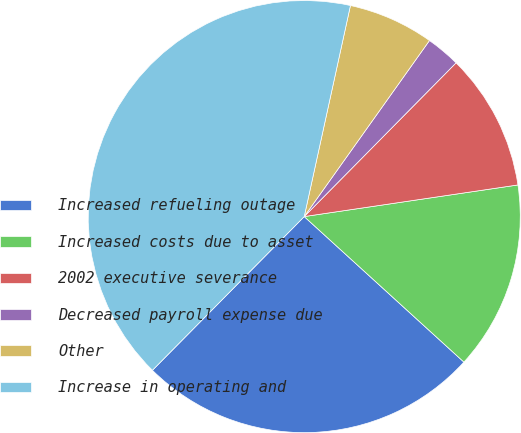<chart> <loc_0><loc_0><loc_500><loc_500><pie_chart><fcel>Increased refueling outage<fcel>Increased costs due to asset<fcel>2002 executive severance<fcel>Decreased payroll expense due<fcel>Other<fcel>Increase in operating and<nl><fcel>25.64%<fcel>14.1%<fcel>10.26%<fcel>2.56%<fcel>6.41%<fcel>41.03%<nl></chart> 